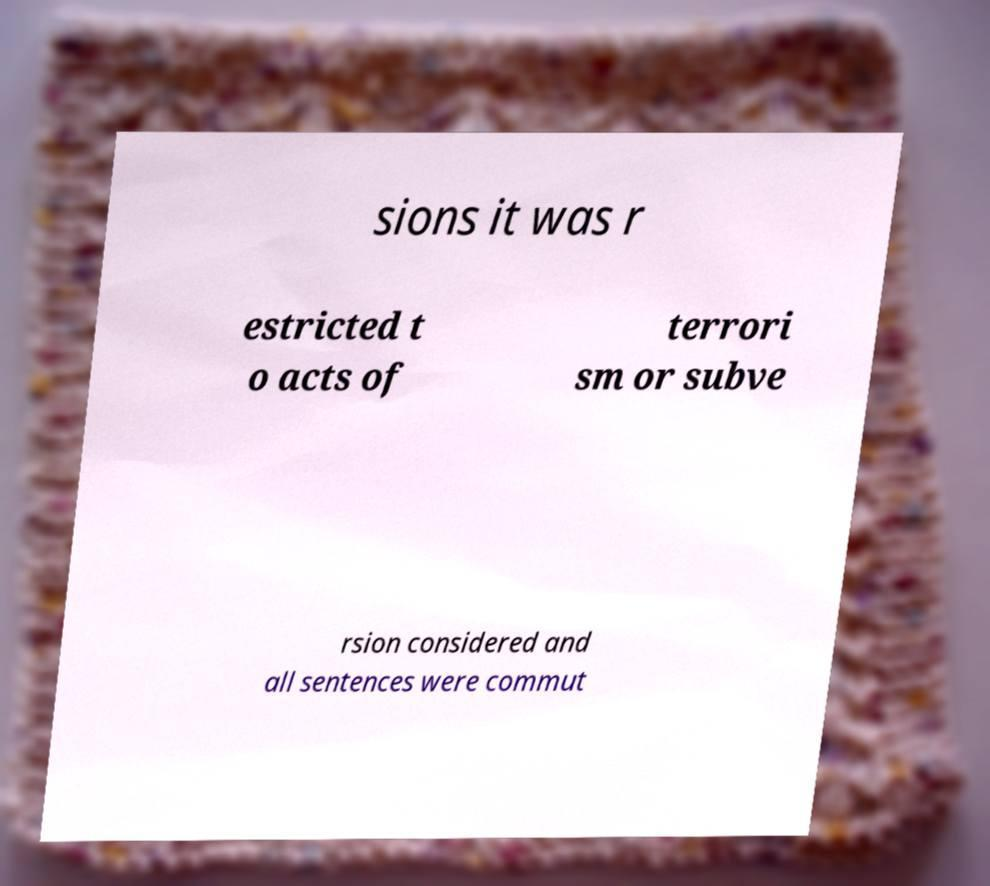What messages or text are displayed in this image? I need them in a readable, typed format. sions it was r estricted t o acts of terrori sm or subve rsion considered and all sentences were commut 